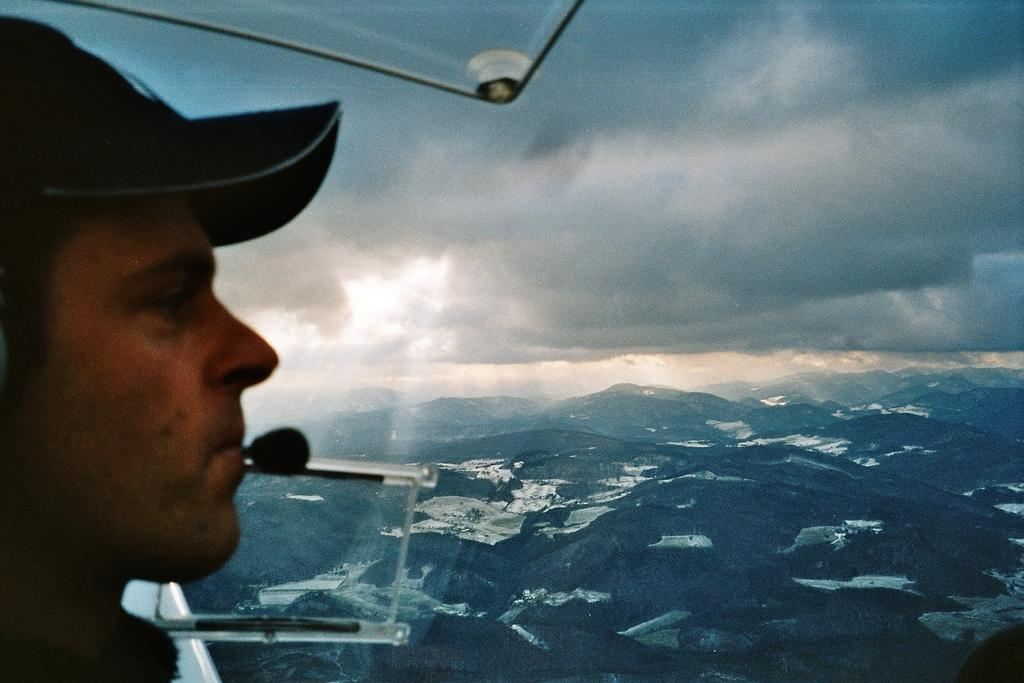Who is present in the image? There is a man in the image. What is the man wearing on his head? The man is wearing a hat. What can be seen at the top of the image? The sky is visible at the top of the image. What type of brick is being used to build the room in the image? There is no room or brick present in the image; it features a man wearing a hat with the sky visible at the top. 